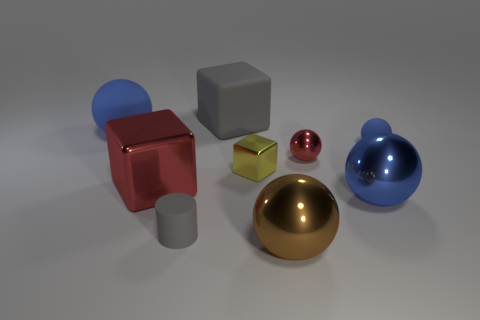Subtract all brown cylinders. How many blue spheres are left? 3 Subtract all red spheres. How many spheres are left? 4 Subtract all tiny blue matte balls. How many balls are left? 4 Subtract all purple spheres. Subtract all brown blocks. How many spheres are left? 5 Add 1 tiny blue shiny cylinders. How many objects exist? 10 Subtract all cylinders. How many objects are left? 8 Add 7 big blue metal balls. How many big blue metal balls are left? 8 Add 7 large brown metal spheres. How many large brown metal spheres exist? 8 Subtract 0 brown cylinders. How many objects are left? 9 Subtract all tiny red objects. Subtract all small balls. How many objects are left? 6 